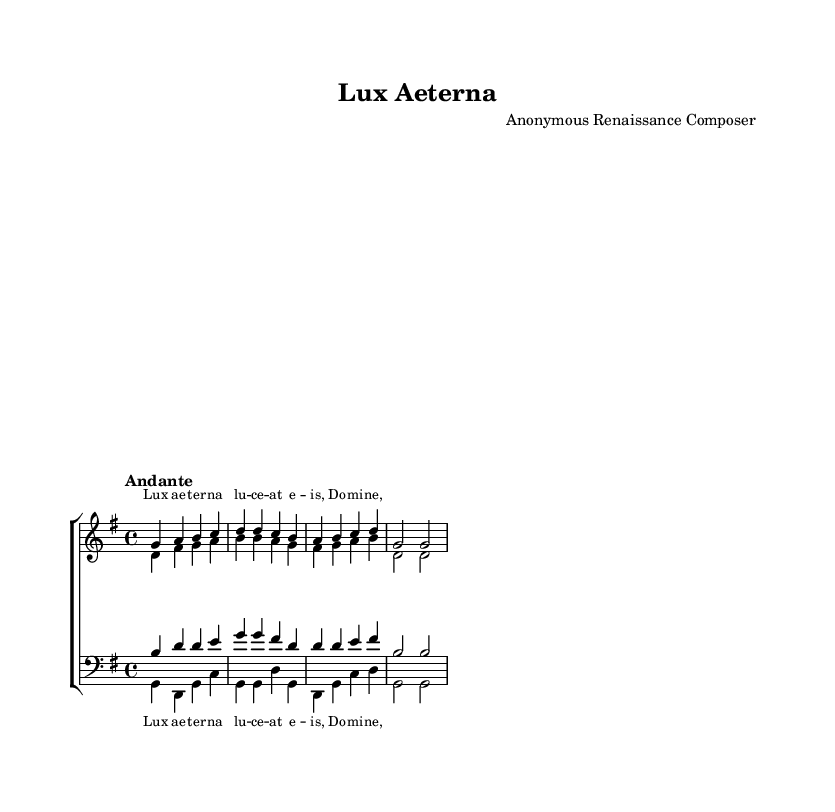What is the key signature of this music? The key signature is G major, which has one sharp (F#). This can be determined by looking at the key signature placed at the beginning of the staff.
Answer: G major What is the time signature of this piece? The time signature is 4/4, indicated at the beginning of the score. This means there are four beats in a measure, and a quarter note gets one beat.
Answer: 4/4 What is the tempo indication for this motet? The tempo indication is "Andante," which suggests a moderately slow pace for the music. This can be found in the tempo marking located at the beginning of the score.
Answer: Andante How many parts are there in this motet? There are four parts: soprano, alto, tenor, and bass, as indicated by the four labeled voices in the score. This can be seen in the layout of the choir staff and the respective staves for each voice.
Answer: Four What is the main lyric text of this motet? The main lyric text of this motet is "Lux aeterna lucet eis, Domine," as seen in the provided verse under the soprano and bass parts. This portion is highlighted in the lyrics section.
Answer: Lux aeterna lucet eis, Domine Which vocal range has the highest pitch in this composition? The highest pitch is in the soprano range, which is noted at the top of the staff with the corresponding soprano music line showing the uppermost notes.
Answer: Soprano What does the presence of the word "Lux" at the beginning signify in this religious context? The word "Lux," meaning "light," signifies a common theme in sacred music, representing divine light or the presence of God. It often corresponds to biblical references, particularly in the context of motets.
Answer: Divine light 